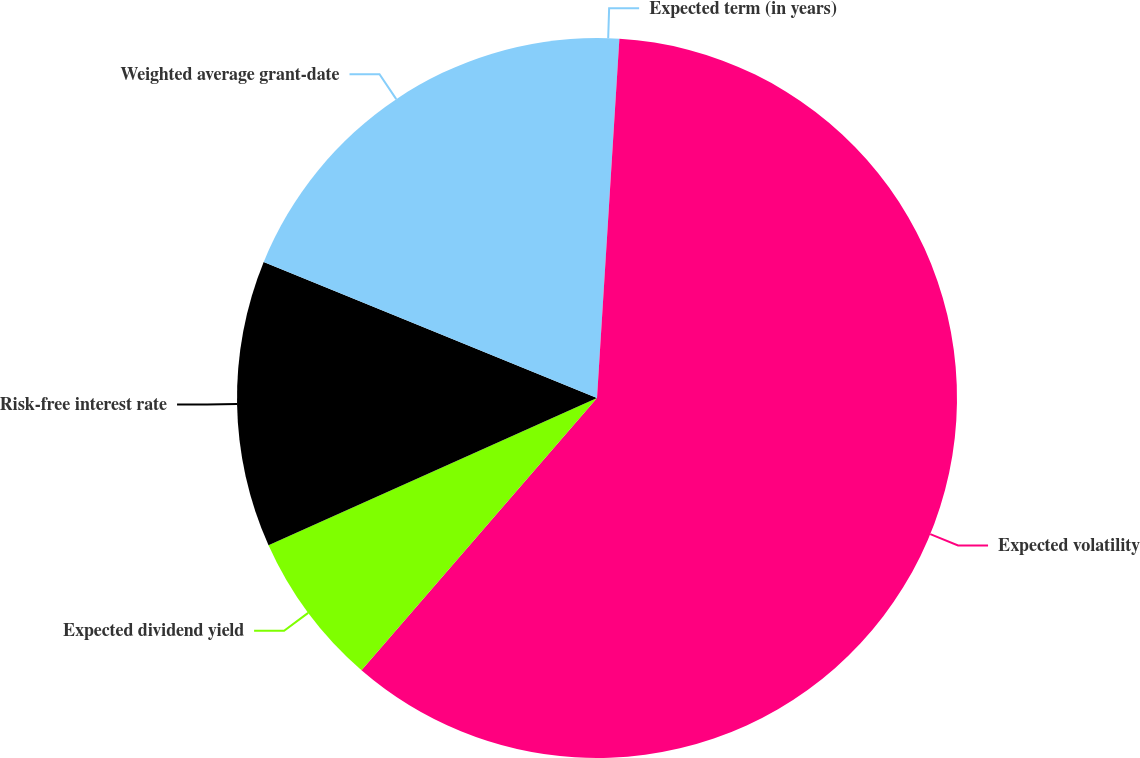<chart> <loc_0><loc_0><loc_500><loc_500><pie_chart><fcel>Expected term (in years)<fcel>Expected volatility<fcel>Expected dividend yield<fcel>Risk-free interest rate<fcel>Weighted average grant-date<nl><fcel>0.99%<fcel>60.36%<fcel>6.94%<fcel>12.88%<fcel>18.83%<nl></chart> 